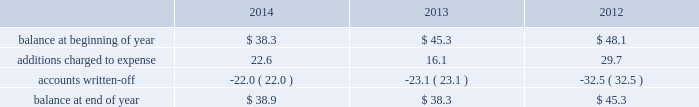Republic services , inc .
Notes to consolidated financial statements 2014 ( continued ) credit exposure , we continually monitor the credit worthiness of the financial institutions where we have deposits .
Concentrations of credit risk with respect to trade accounts receivable are limited due to the wide variety of customers and markets in which we provide services , as well as the dispersion of our operations across many geographic areas .
We provide services to commercial , industrial , municipal and residential customers in the united states and puerto rico .
We perform ongoing credit evaluations of our customers , but generally do not require collateral to support customer receivables .
We establish an allowance for doubtful accounts based on various factors including the credit risk of specific customers , age of receivables outstanding , historical trends , economic conditions and other information .
Accounts receivable , net accounts receivable represent receivables from customers for collection , transfer , recycling , disposal and other services .
Our receivables are recorded when billed or when the related revenue is earned , if earlier , and represent claims against third parties that will be settled in cash .
The carrying value of our receivables , net of the allowance for doubtful accounts and customer credits , represents their estimated net realizable value .
Provisions for doubtful accounts are evaluated on a monthly basis and are recorded based on our historical collection experience , the age of the receivables , specific customer information and economic conditions .
We also review outstanding balances on an account-specific basis .
In general , reserves are provided for accounts receivable in excess of 90 days outstanding .
Past due receivable balances are written-off when our collection efforts have been unsuccessful in collecting amounts due .
The table reflects the activity in our allowance for doubtful accounts for the years ended december 31: .
Restricted cash and marketable securities as of december 31 , 2014 , we had $ 115.6 million of restricted cash and marketable securities .
We obtain funds through the issuance of tax-exempt bonds for the purpose of financing qualifying expenditures at our landfills , transfer stations , collection and recycling centers .
The funds are deposited directly into trust accounts by the bonding authorities at the time of issuance .
As the use of these funds is contractually restricted , and we do not have the ability to use these funds for general operating purposes , they are classified as restricted cash and marketable securities in our consolidated balance sheets .
In the normal course of business , we may be required to provide financial assurance to governmental agencies and a variety of other entities in connection with municipal residential collection contracts , closure or post- closure of landfills , environmental remediation , environmental permits , and business licenses and permits as a financial guarantee of our performance .
At several of our landfills , we satisfy financial assurance requirements by depositing cash into restricted trust funds or escrow accounts .
Property and equipment we record property and equipment at cost .
Expenditures for major additions and improvements to facilities are capitalized , while maintenance and repairs are charged to expense as incurred .
When property is retired or otherwise disposed , the related cost and accumulated depreciation are removed from the accounts and any resulting gain or loss is reflected in the consolidated statements of income. .
What was the percentage decline in the allowance for doubtful accounts in 2013? 
Computations: ((38.3 - 45.3) / 45.3)
Answer: -0.15453. 